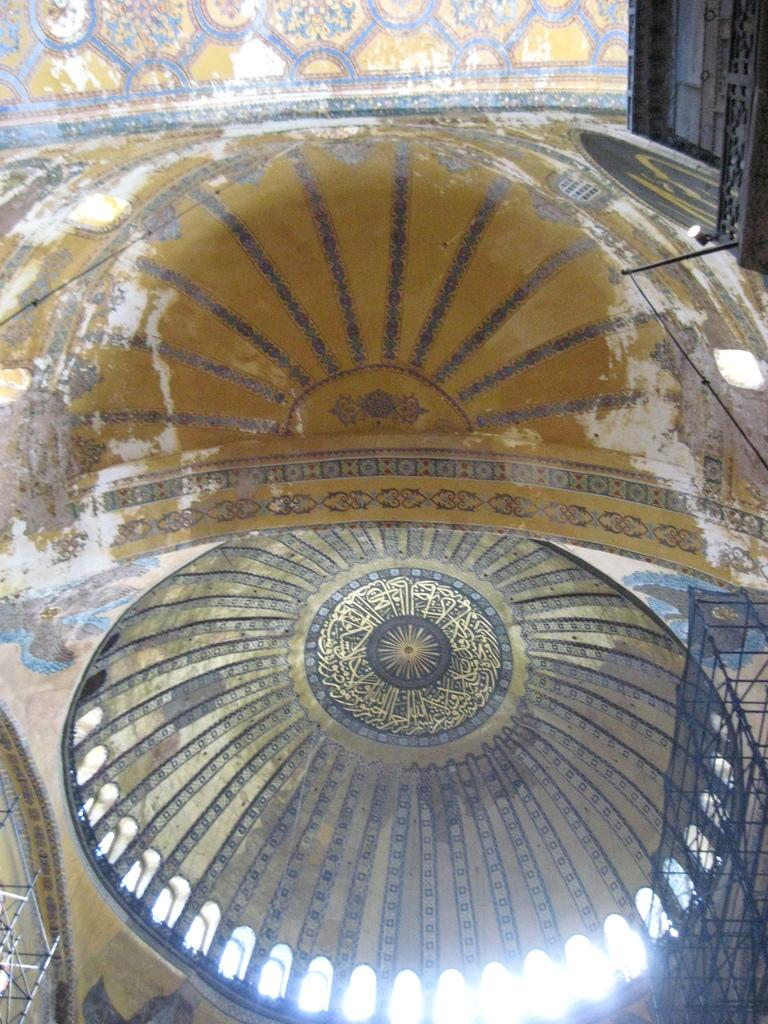Where was the image taken? The image was taken in a hall. What can be seen above the hall in the image? There is a roof visible in the image. What feature is present to provide safety or support in the image? Railings are present in the image. What type of engine can be seen in the image? There is no engine present in the image; it is taken in a hall with a roof and railings. 